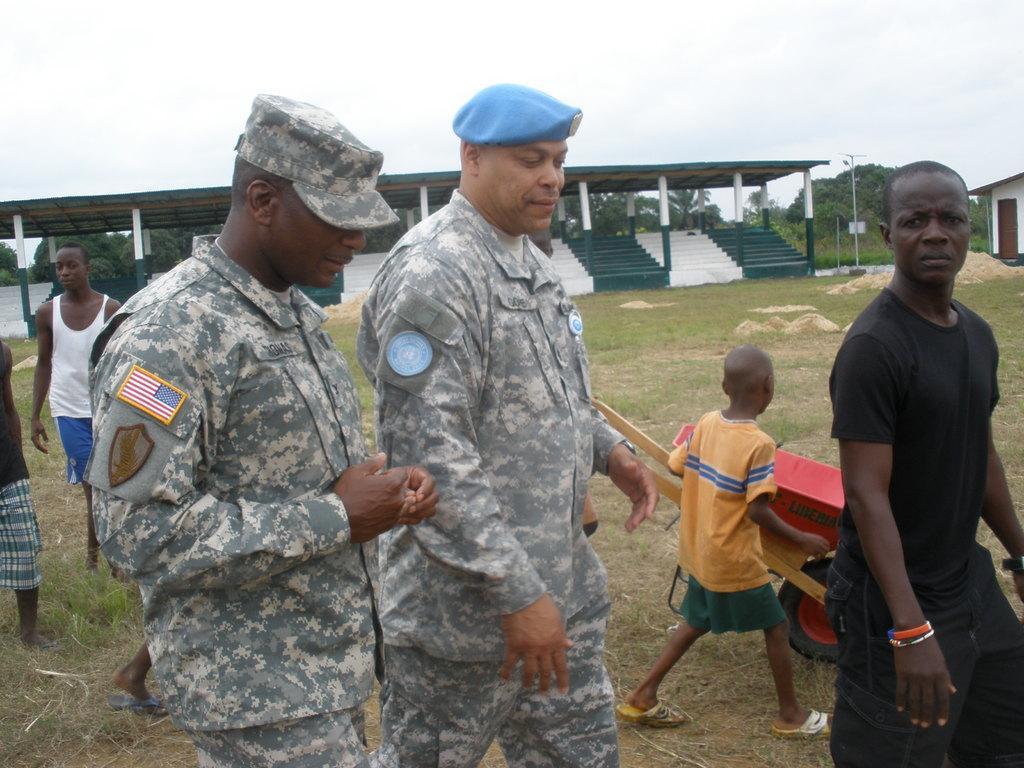Can you describe this image briefly? In this picture there are people and we can see cart on the grass. In the background of the image we can see sheds, poles, trees, steps and sky. 